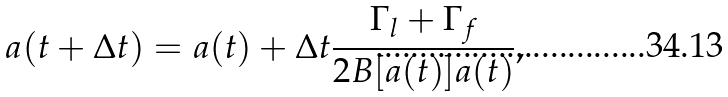<formula> <loc_0><loc_0><loc_500><loc_500>a ( t + \Delta t ) = a ( t ) + \Delta t \frac { \Gamma _ { l } + \Gamma _ { f } } { 2 B [ a ( t ) ] a ( t ) } ,</formula> 